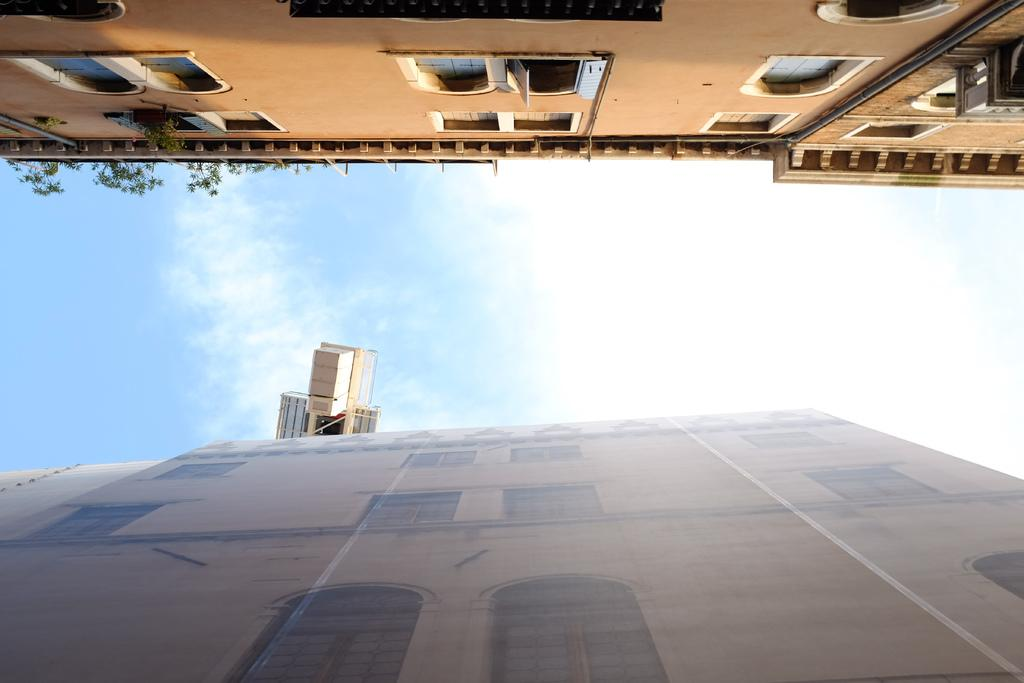What type of structures can be seen in the image? There are buildings in the image. What other elements are present in the image besides buildings? There are plants and other objects in the image. What can be seen in the background of the image? The sky is visible in the background of the image. What flavor of cream is being used to water the plants in the image? There is no cream present in the image, and plants are not watered with cream. 